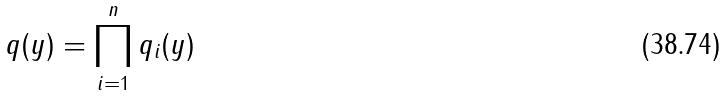<formula> <loc_0><loc_0><loc_500><loc_500>q ( y ) = \prod _ { i = 1 } ^ { n } q _ { i } ( y )</formula> 